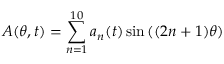<formula> <loc_0><loc_0><loc_500><loc_500>A ( \theta , t ) = \sum _ { n = 1 } ^ { 1 0 } a _ { n } ( t ) \sin { ( ( 2 n + 1 ) \theta ) }</formula> 